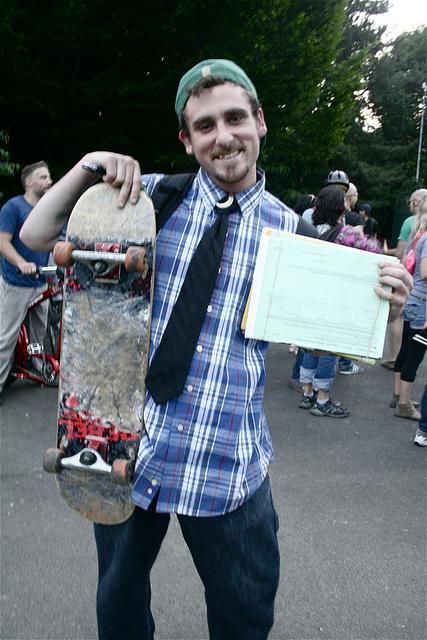Is this man happy or worried?
Write a very short answer. Happy. Does this man need a new skateboard?
Quick response, please. Yes. What continent is this picture likely from?
Write a very short answer. North america. What is in the man's left hand?
Keep it brief. Papers. 